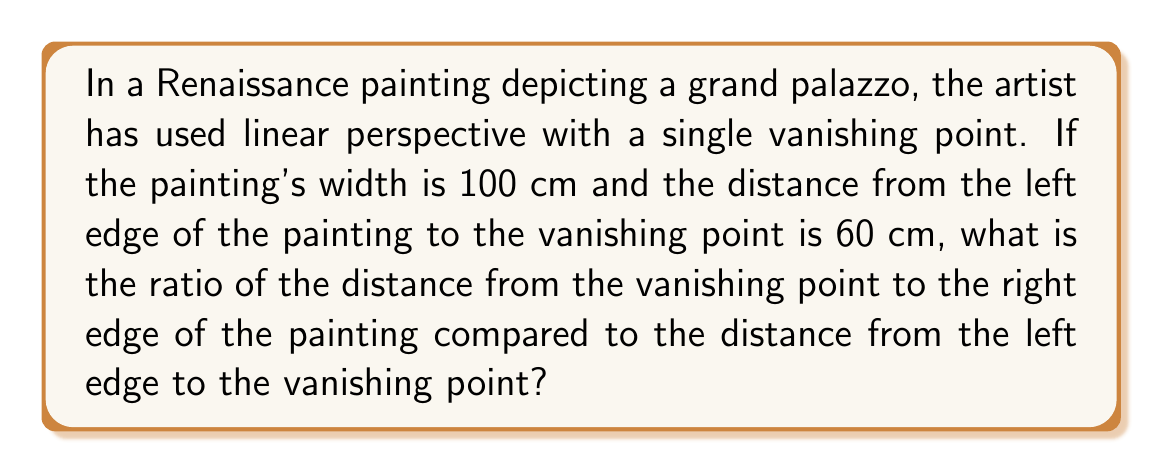Provide a solution to this math problem. To solve this problem, we need to follow these steps:

1. Understand the given information:
   - The painting's total width is 100 cm
   - The distance from the left edge to the vanishing point is 60 cm

2. Calculate the distance from the vanishing point to the right edge:
   - Distance to right edge = Total width - Distance from left edge
   - Distance to right edge = 100 cm - 60 cm = 40 cm

3. Set up the ratio:
   - We want to compare the distance from the vanishing point to the right edge (40 cm) with the distance from the left edge to the vanishing point (60 cm)
   - Ratio = $\frac{\text{Distance to right edge}}{\text{Distance from left edge}}$
   - Ratio = $\frac{40}{60}$

4. Simplify the ratio:
   - $\frac{40}{60} = \frac{2}{3}$

This ratio tells us that the distance from the vanishing point to the right edge is $\frac{2}{3}$ of the distance from the left edge to the vanishing point. This asymmetry in the placement of the vanishing point is a common technique used by Renaissance artists to create a more dynamic and interesting composition while still maintaining the illusion of depth and perspective.
Answer: $\frac{2}{3}$ 